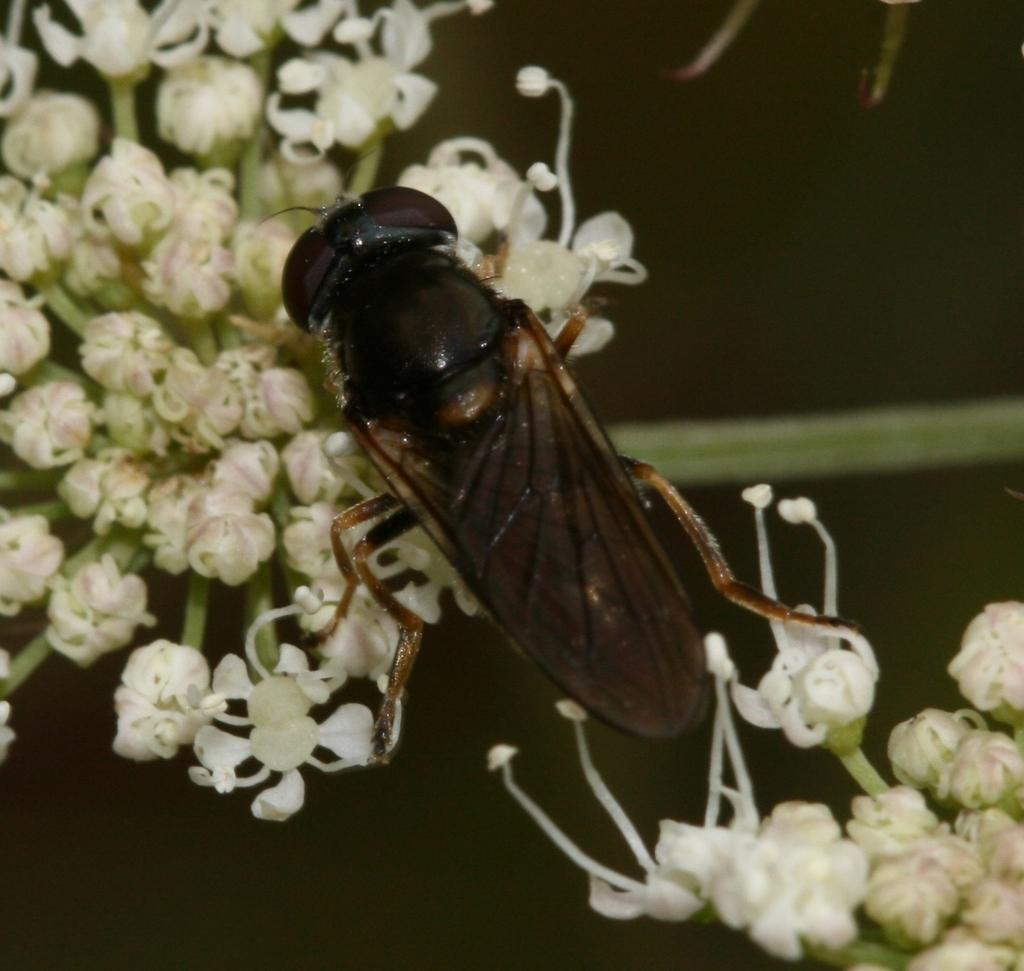What is the main subject of the image? There is an insect in the center of the image. What is the insect doing or situated on? The insect is on flowers. How would you describe the background of the image? The background of the image is blurry. What type of watch is the brother wearing in the image? There is no brother or watch present in the image; it features an insect on flowers with a blurry background. 